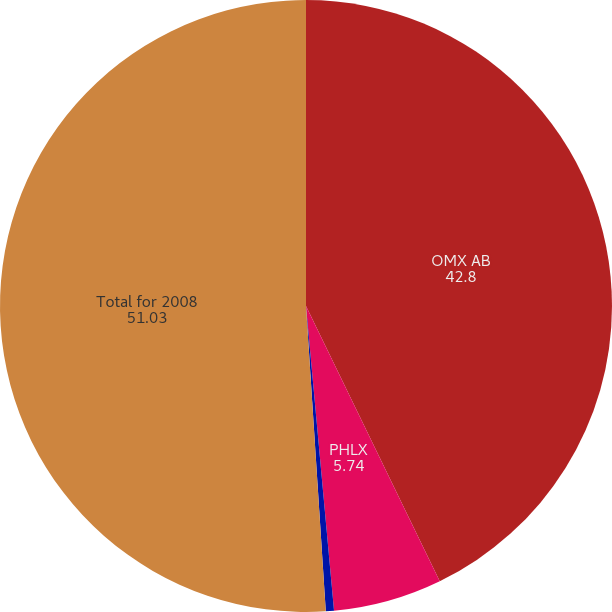<chart> <loc_0><loc_0><loc_500><loc_500><pie_chart><fcel>OMX AB<fcel>PHLX<fcel>BSX<fcel>Total for 2008<nl><fcel>42.8%<fcel>5.74%<fcel>0.43%<fcel>51.03%<nl></chart> 